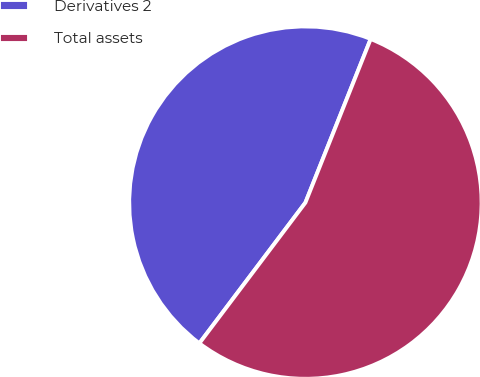Convert chart to OTSL. <chart><loc_0><loc_0><loc_500><loc_500><pie_chart><fcel>Derivatives 2<fcel>Total assets<nl><fcel>45.76%<fcel>54.24%<nl></chart> 